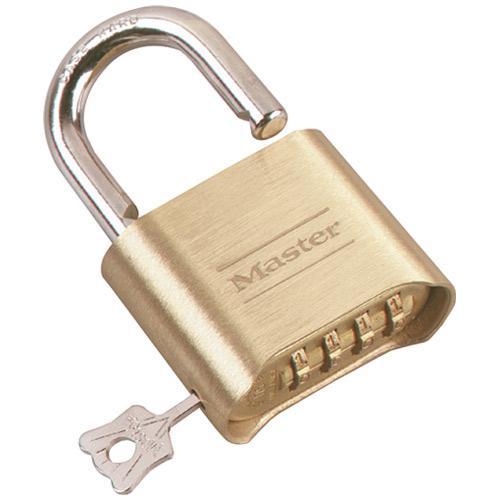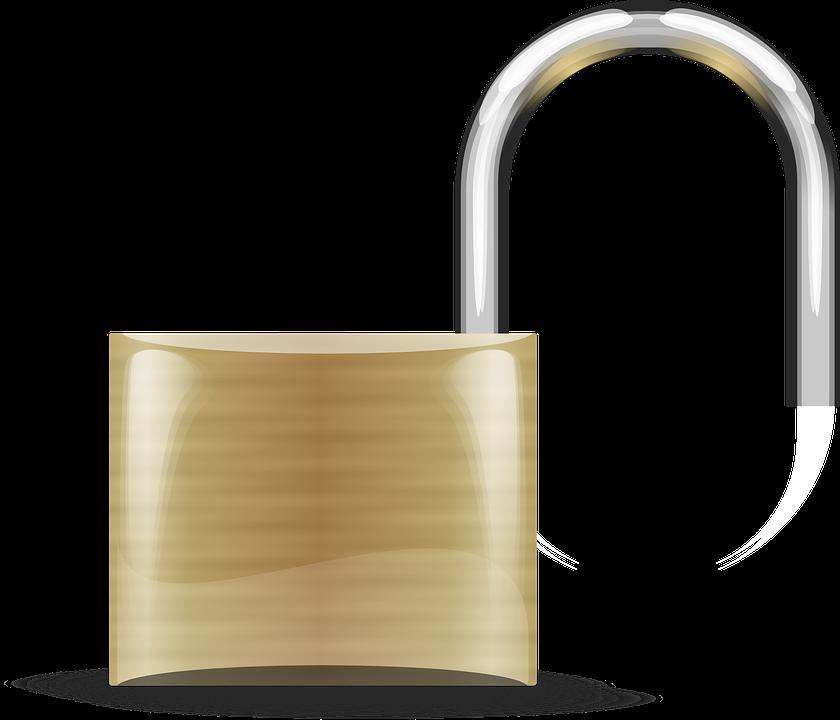The first image is the image on the left, the second image is the image on the right. For the images displayed, is the sentence "One or more locks have their rotating discs showing on the side, while another lock does not have them on the side." factually correct? Answer yes or no. No. The first image is the image on the left, the second image is the image on the right. Assess this claim about the two images: "At least one of the locks has a black body with at least three rows of combination wheels on its front.". Correct or not? Answer yes or no. No. 